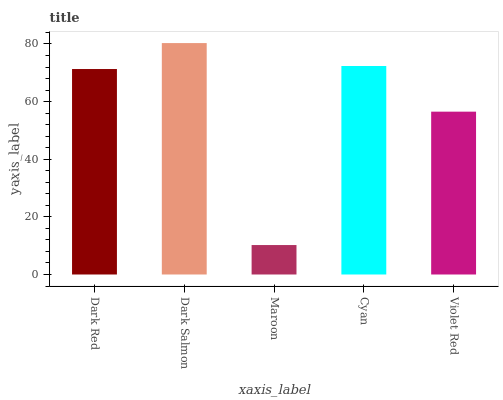Is Maroon the minimum?
Answer yes or no. Yes. Is Dark Salmon the maximum?
Answer yes or no. Yes. Is Dark Salmon the minimum?
Answer yes or no. No. Is Maroon the maximum?
Answer yes or no. No. Is Dark Salmon greater than Maroon?
Answer yes or no. Yes. Is Maroon less than Dark Salmon?
Answer yes or no. Yes. Is Maroon greater than Dark Salmon?
Answer yes or no. No. Is Dark Salmon less than Maroon?
Answer yes or no. No. Is Dark Red the high median?
Answer yes or no. Yes. Is Dark Red the low median?
Answer yes or no. Yes. Is Maroon the high median?
Answer yes or no. No. Is Violet Red the low median?
Answer yes or no. No. 